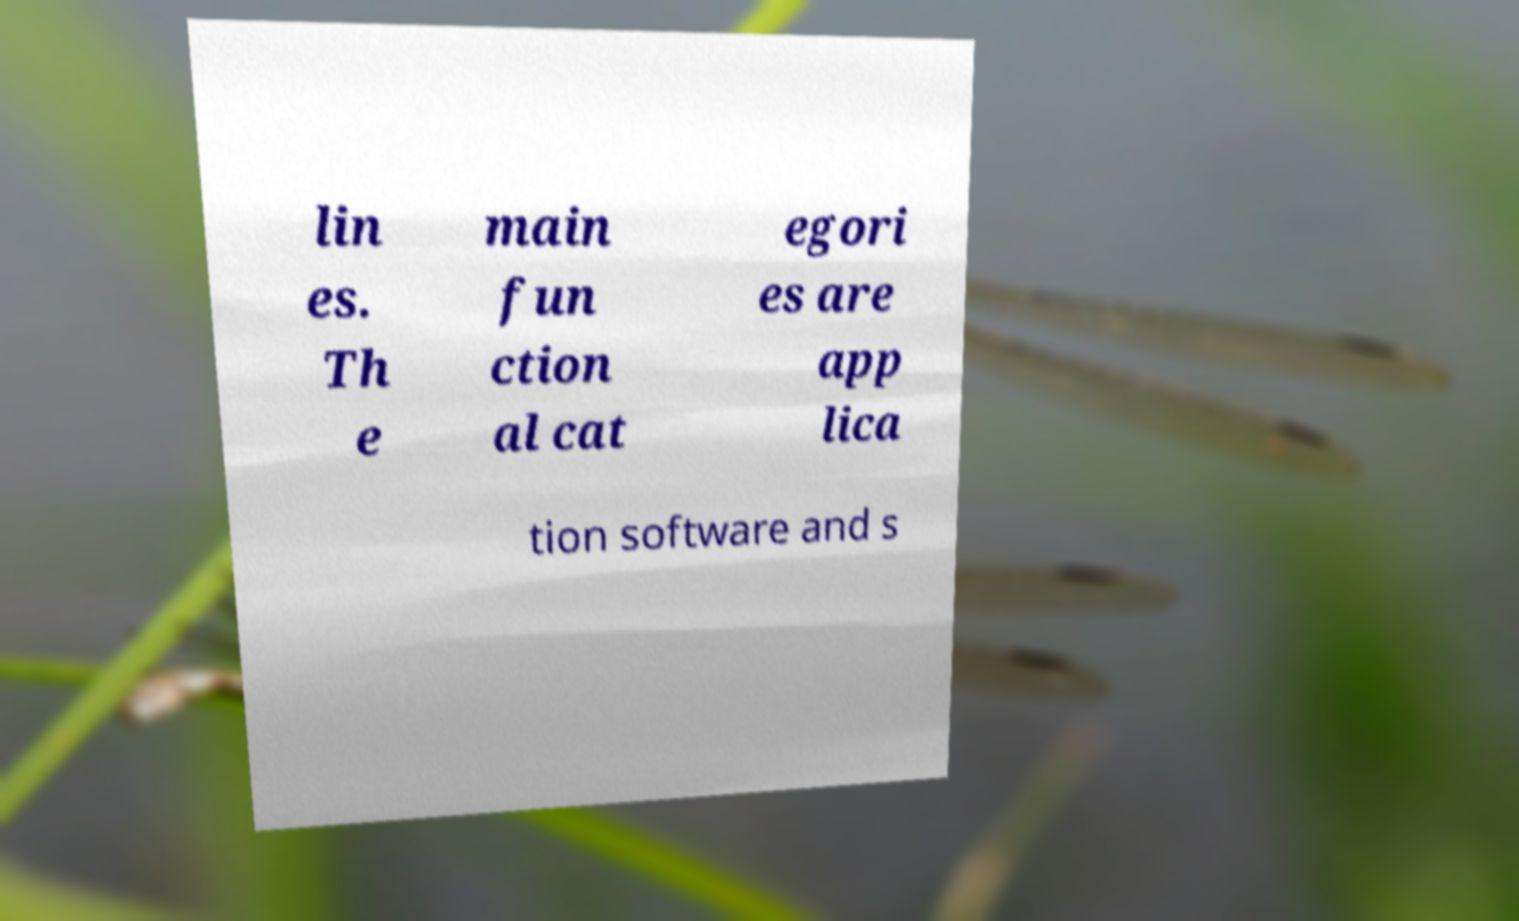Can you accurately transcribe the text from the provided image for me? lin es. Th e main fun ction al cat egori es are app lica tion software and s 